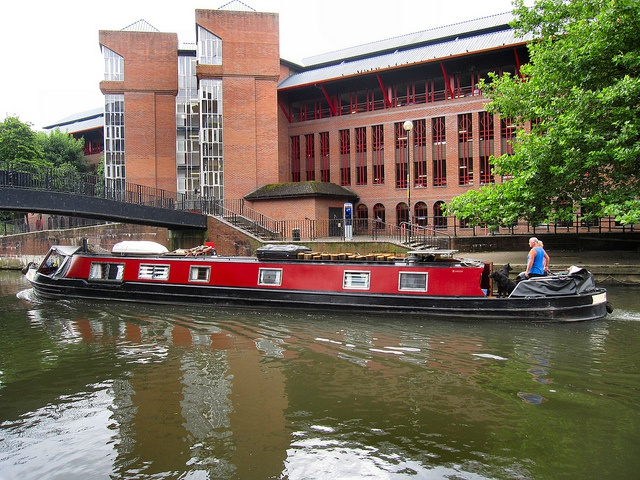Describe the objects in this image and their specific colors. I can see boat in white, black, gray, brown, and lightgray tones, people in white, salmon, black, blue, and brown tones, dog in white, black, and gray tones, and people in white, gray, and black tones in this image. 